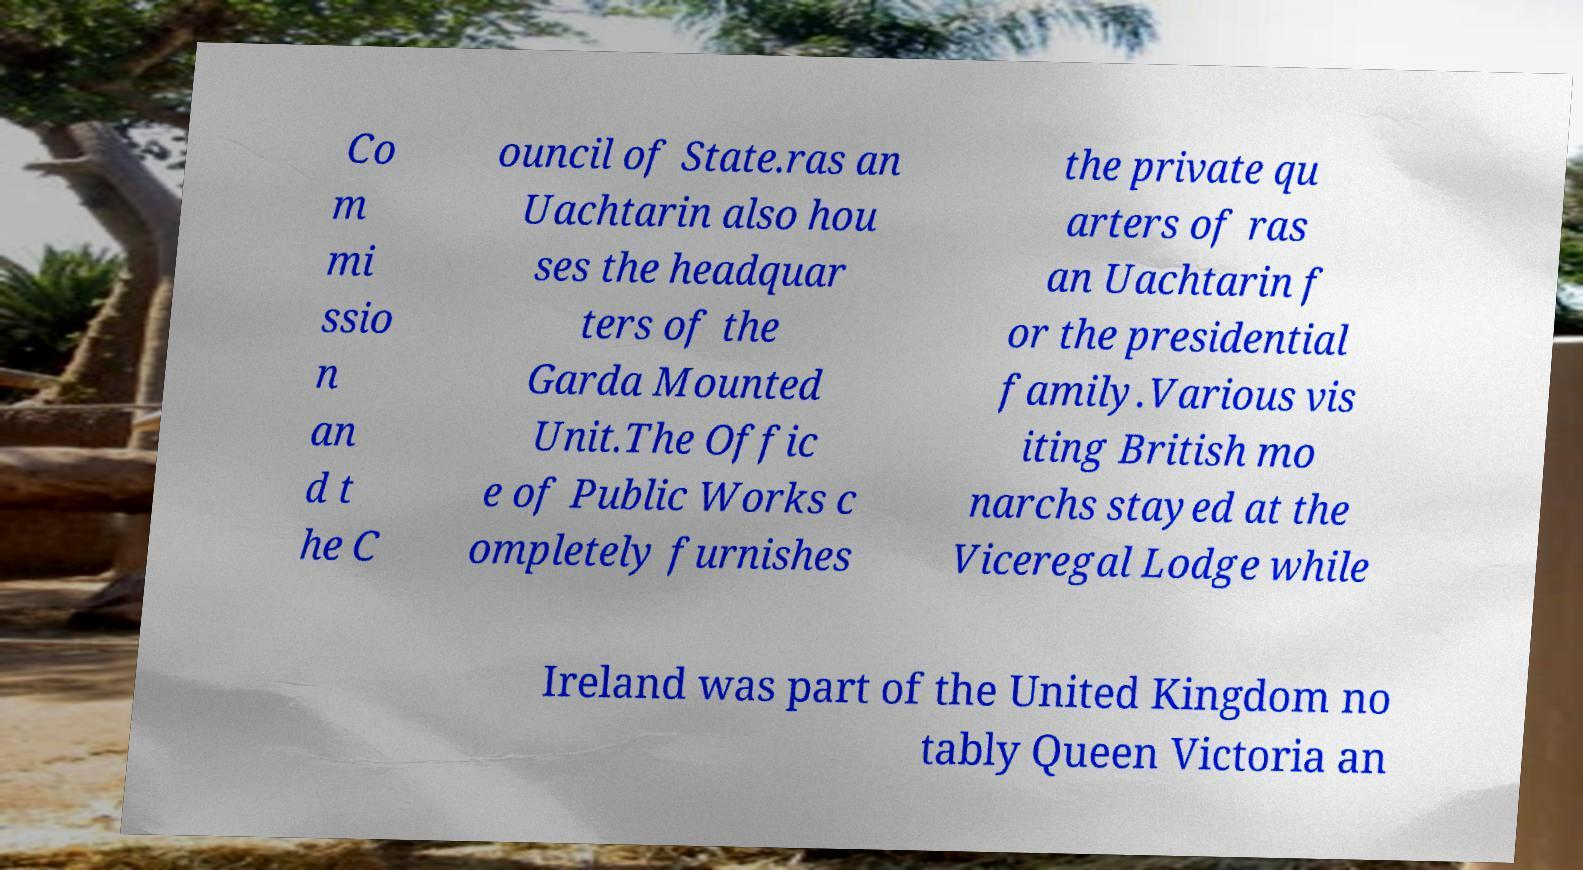Please identify and transcribe the text found in this image. Co m mi ssio n an d t he C ouncil of State.ras an Uachtarin also hou ses the headquar ters of the Garda Mounted Unit.The Offic e of Public Works c ompletely furnishes the private qu arters of ras an Uachtarin f or the presidential family.Various vis iting British mo narchs stayed at the Viceregal Lodge while Ireland was part of the United Kingdom no tably Queen Victoria an 